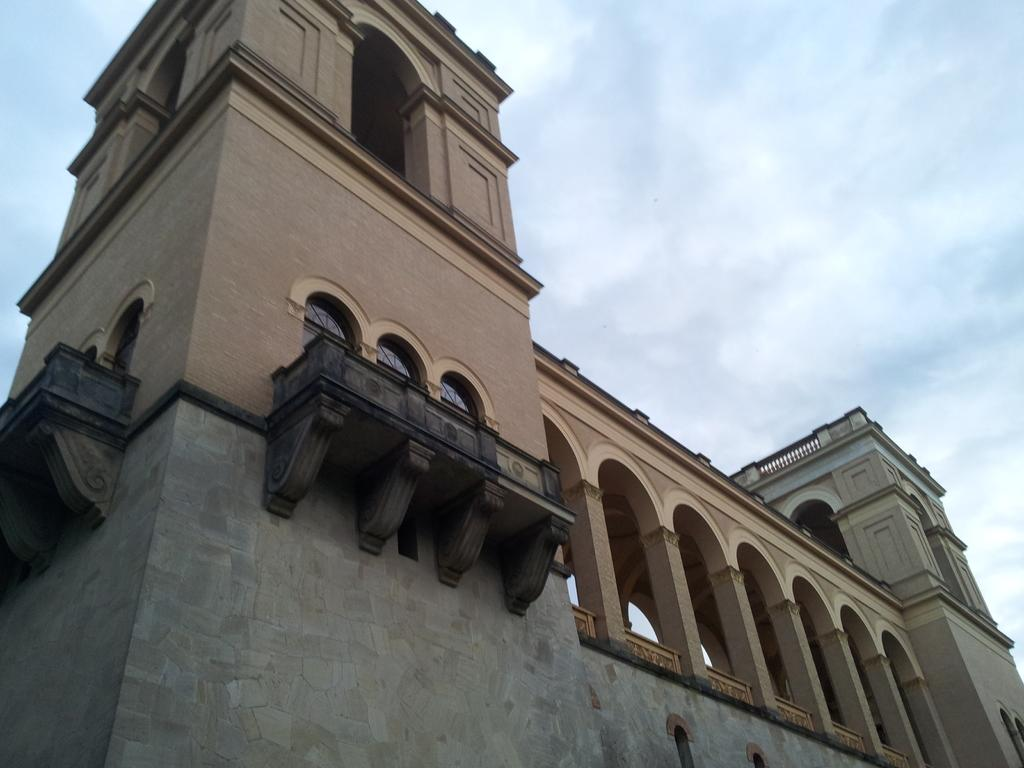Where might the image have been taken? The image might have been taken outside of a building. What architectural features can be seen in the image? There are pillars visible in the image. What can be seen through the window in the image? The sky is visible at the top of the image. What type of drum can be heard playing in the image? There is no drum or sound present in the image, as it is a still photograph. 